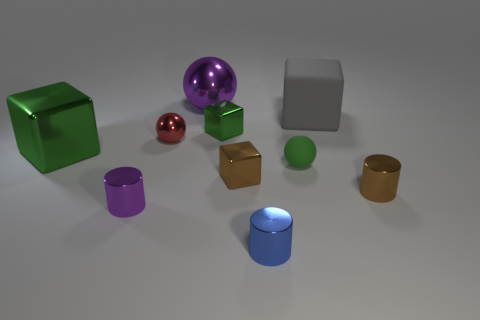Subtract all red cubes. Subtract all purple balls. How many cubes are left? 4 Subtract all cylinders. How many objects are left? 7 Add 9 small purple metal blocks. How many small purple metal blocks exist? 9 Subtract 0 purple cubes. How many objects are left? 10 Subtract all tiny green cubes. Subtract all brown cylinders. How many objects are left? 8 Add 6 small purple cylinders. How many small purple cylinders are left? 7 